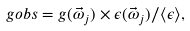Convert formula to latex. <formula><loc_0><loc_0><loc_500><loc_500>\ g o b s = g ( \vec { \omega } _ { j } ) \times \epsilon ( \vec { \omega } _ { j } ) / \langle \epsilon \rangle ,</formula> 